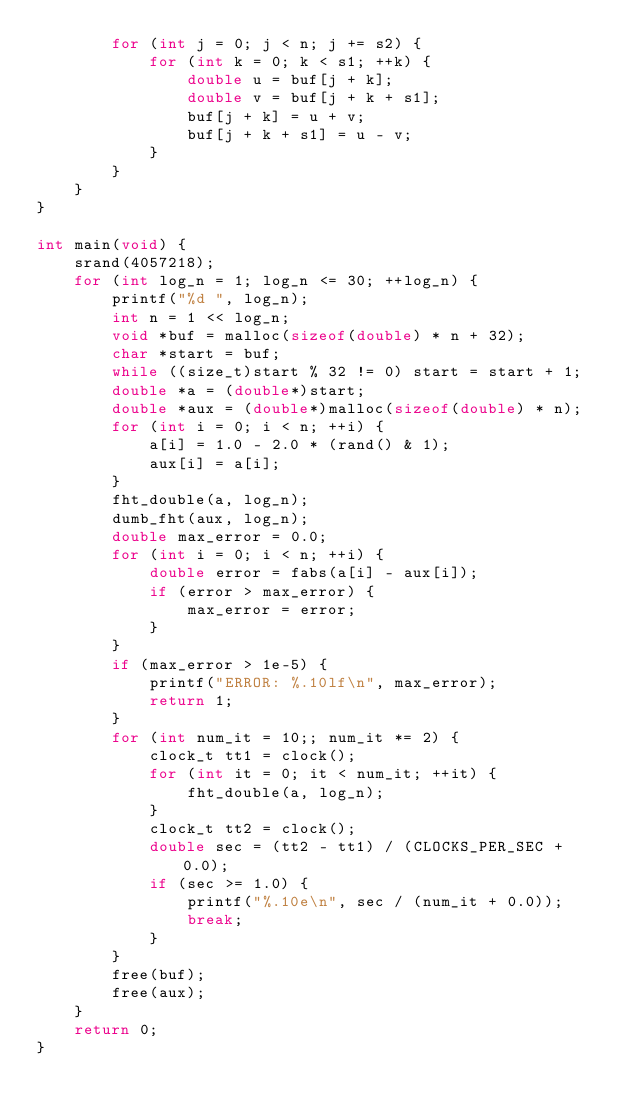<code> <loc_0><loc_0><loc_500><loc_500><_C_>        for (int j = 0; j < n; j += s2) {
            for (int k = 0; k < s1; ++k) {
                double u = buf[j + k];
                double v = buf[j + k + s1];
                buf[j + k] = u + v;
                buf[j + k + s1] = u - v;
            }
        }
    }
}

int main(void) {
    srand(4057218);
    for (int log_n = 1; log_n <= 30; ++log_n) {
        printf("%d ", log_n);
        int n = 1 << log_n;
        void *buf = malloc(sizeof(double) * n + 32);
        char *start = buf;
        while ((size_t)start % 32 != 0) start = start + 1;
        double *a = (double*)start;
        double *aux = (double*)malloc(sizeof(double) * n);
        for (int i = 0; i < n; ++i) {
            a[i] = 1.0 - 2.0 * (rand() & 1);
            aux[i] = a[i];
        }
        fht_double(a, log_n);
        dumb_fht(aux, log_n);
        double max_error = 0.0;
        for (int i = 0; i < n; ++i) {
            double error = fabs(a[i] - aux[i]);
            if (error > max_error) {
                max_error = error;
            }
        }
        if (max_error > 1e-5) {
            printf("ERROR: %.10lf\n", max_error);
            return 1;
        }
        for (int num_it = 10;; num_it *= 2) {
            clock_t tt1 = clock();
            for (int it = 0; it < num_it; ++it) {
                fht_double(a, log_n);
            }
            clock_t tt2 = clock();
            double sec = (tt2 - tt1) / (CLOCKS_PER_SEC + 0.0);
            if (sec >= 1.0) {
                printf("%.10e\n", sec / (num_it + 0.0));
                break;
            }
        }
        free(buf);
        free(aux);
    }
    return 0;
}
</code> 